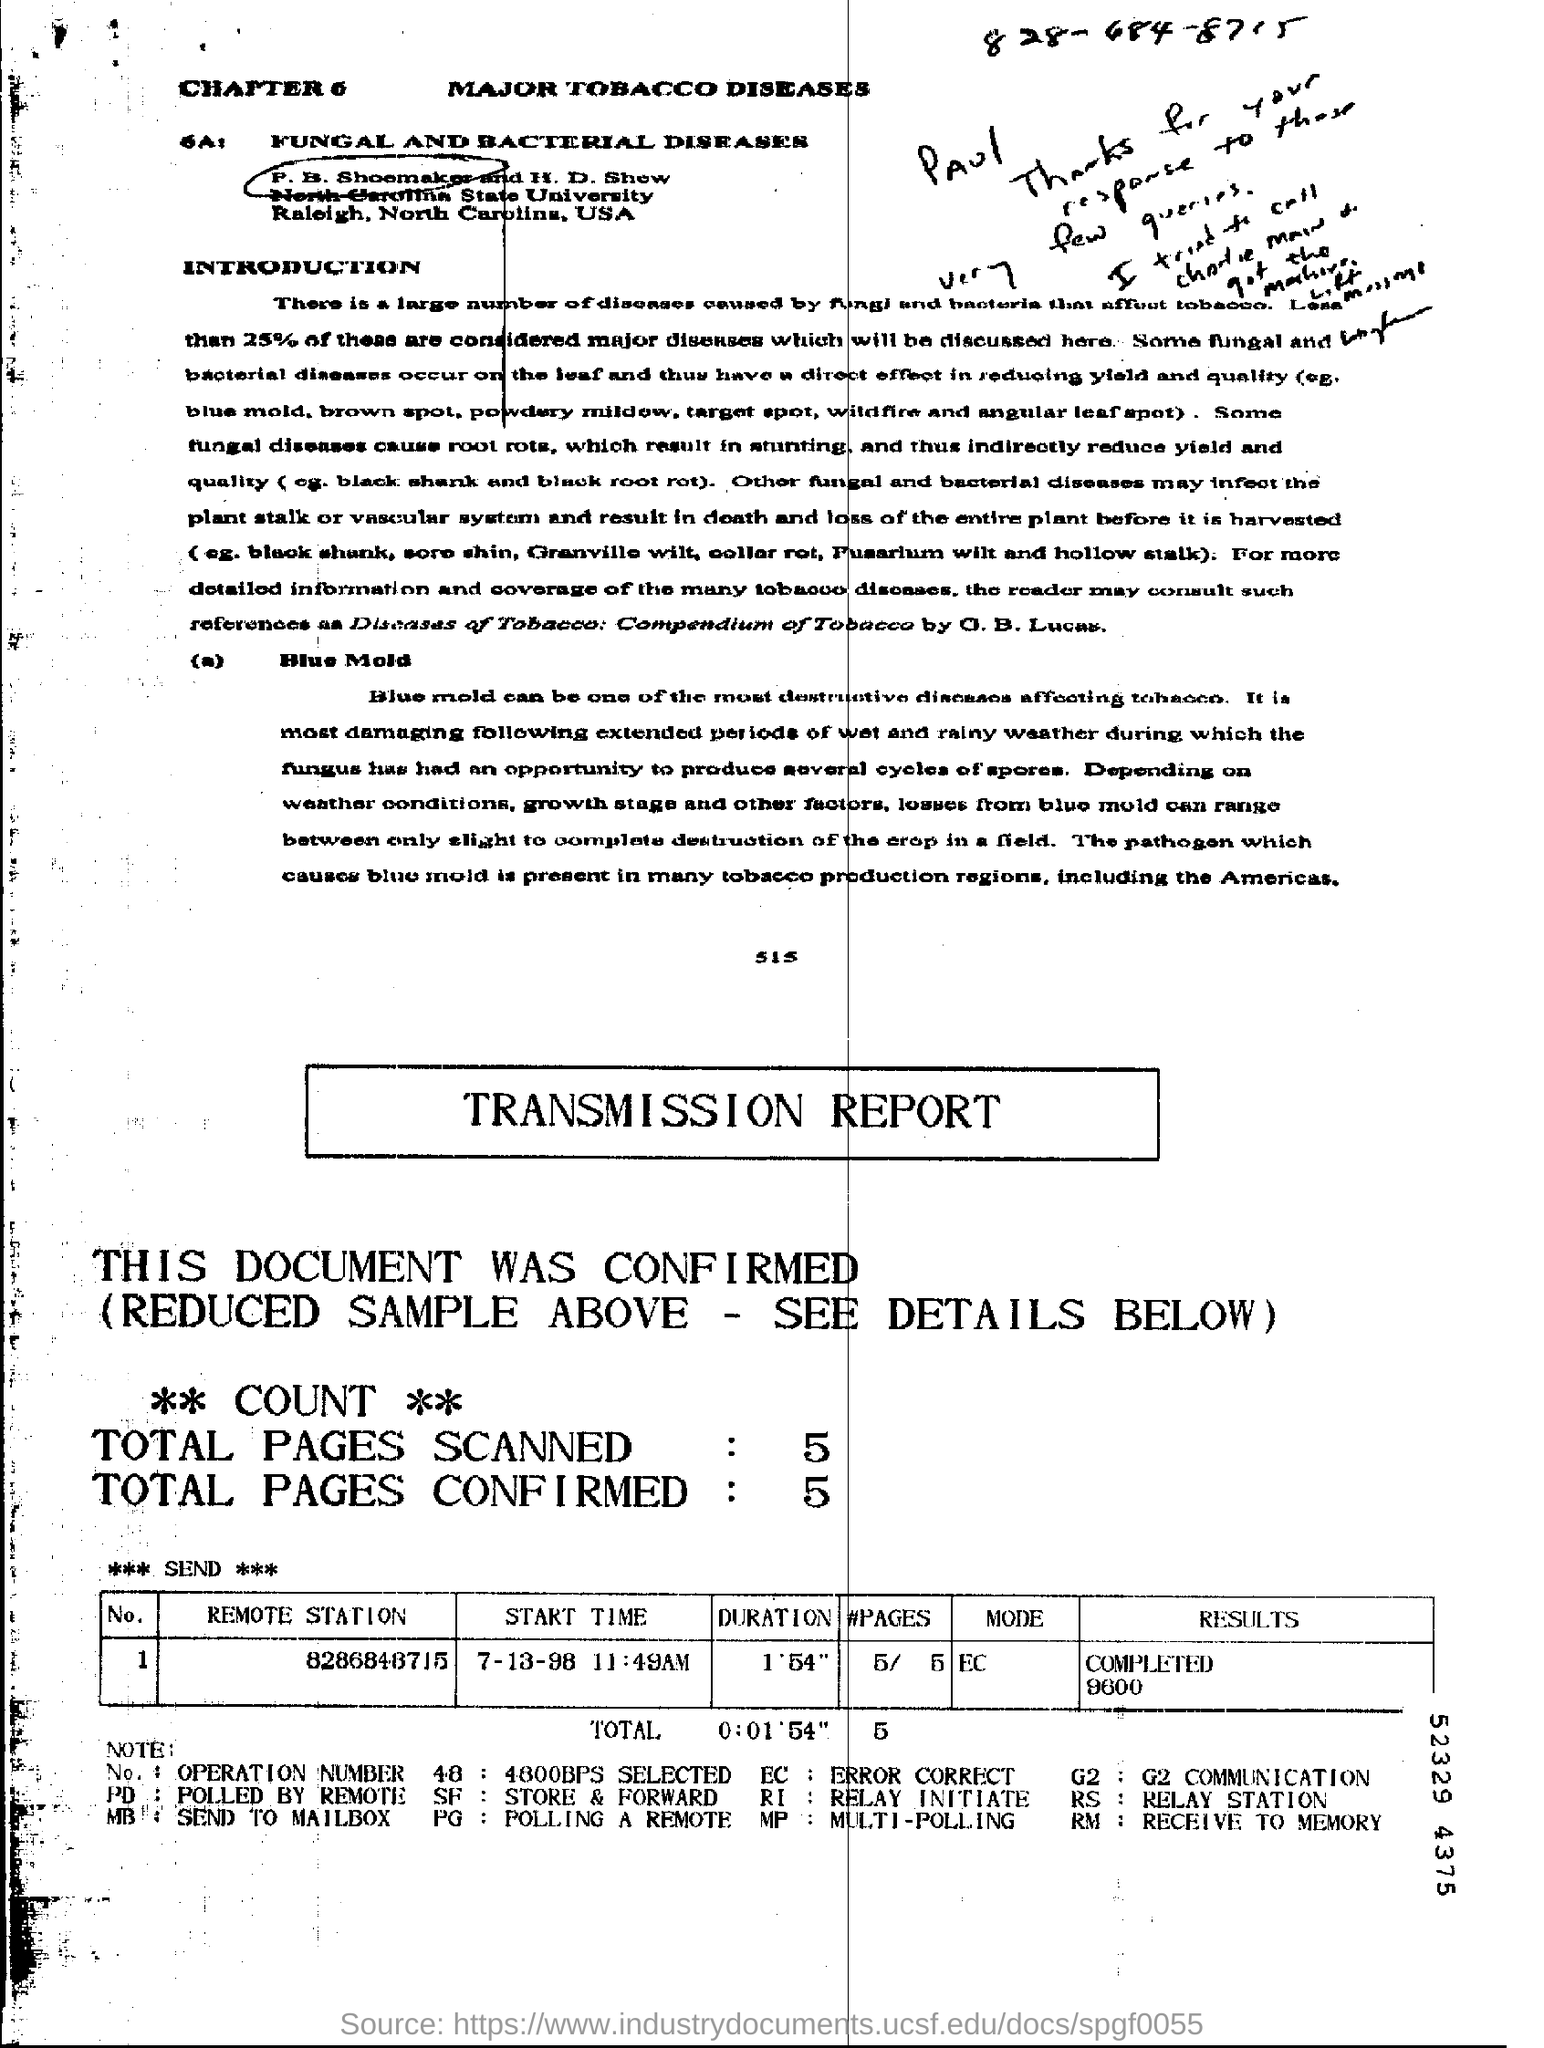What is the name of the chapter?
Give a very brief answer. MAJOR TOBACCO DISEASES. In total how many pages were scanned?
Give a very brief answer. 5. What does SF stand for?
Offer a terse response. Store & forward. What is the remote station number?
Your answer should be very brief. 8286848715. 